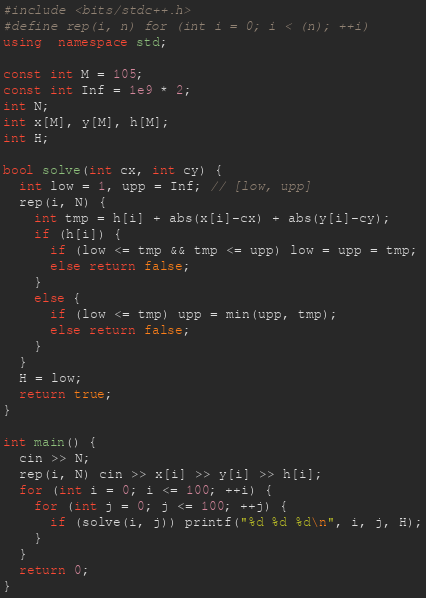Convert code to text. <code><loc_0><loc_0><loc_500><loc_500><_C++_>#include <bits/stdc++.h>
#define rep(i, n) for (int i = 0; i < (n); ++i)
using  namespace std;

const int M = 105;
const int Inf = 1e9 * 2;
int N;
int x[M], y[M], h[M];
int H;

bool solve(int cx, int cy) {
  int low = 1, upp = Inf; // [low, upp]
  rep(i, N) {
    int tmp = h[i] + abs(x[i]-cx) + abs(y[i]-cy);
    if (h[i]) {
      if (low <= tmp && tmp <= upp) low = upp = tmp;
      else return false;
    }
    else {
      if (low <= tmp) upp = min(upp, tmp);
      else return false;
    }
  }
  H = low;
  return true;
}

int main() {
  cin >> N;
  rep(i, N) cin >> x[i] >> y[i] >> h[i];
  for (int i = 0; i <= 100; ++i) {
    for (int j = 0; j <= 100; ++j) {
      if (solve(i, j)) printf("%d %d %d\n", i, j, H);
    }
  }
  return 0;
}</code> 